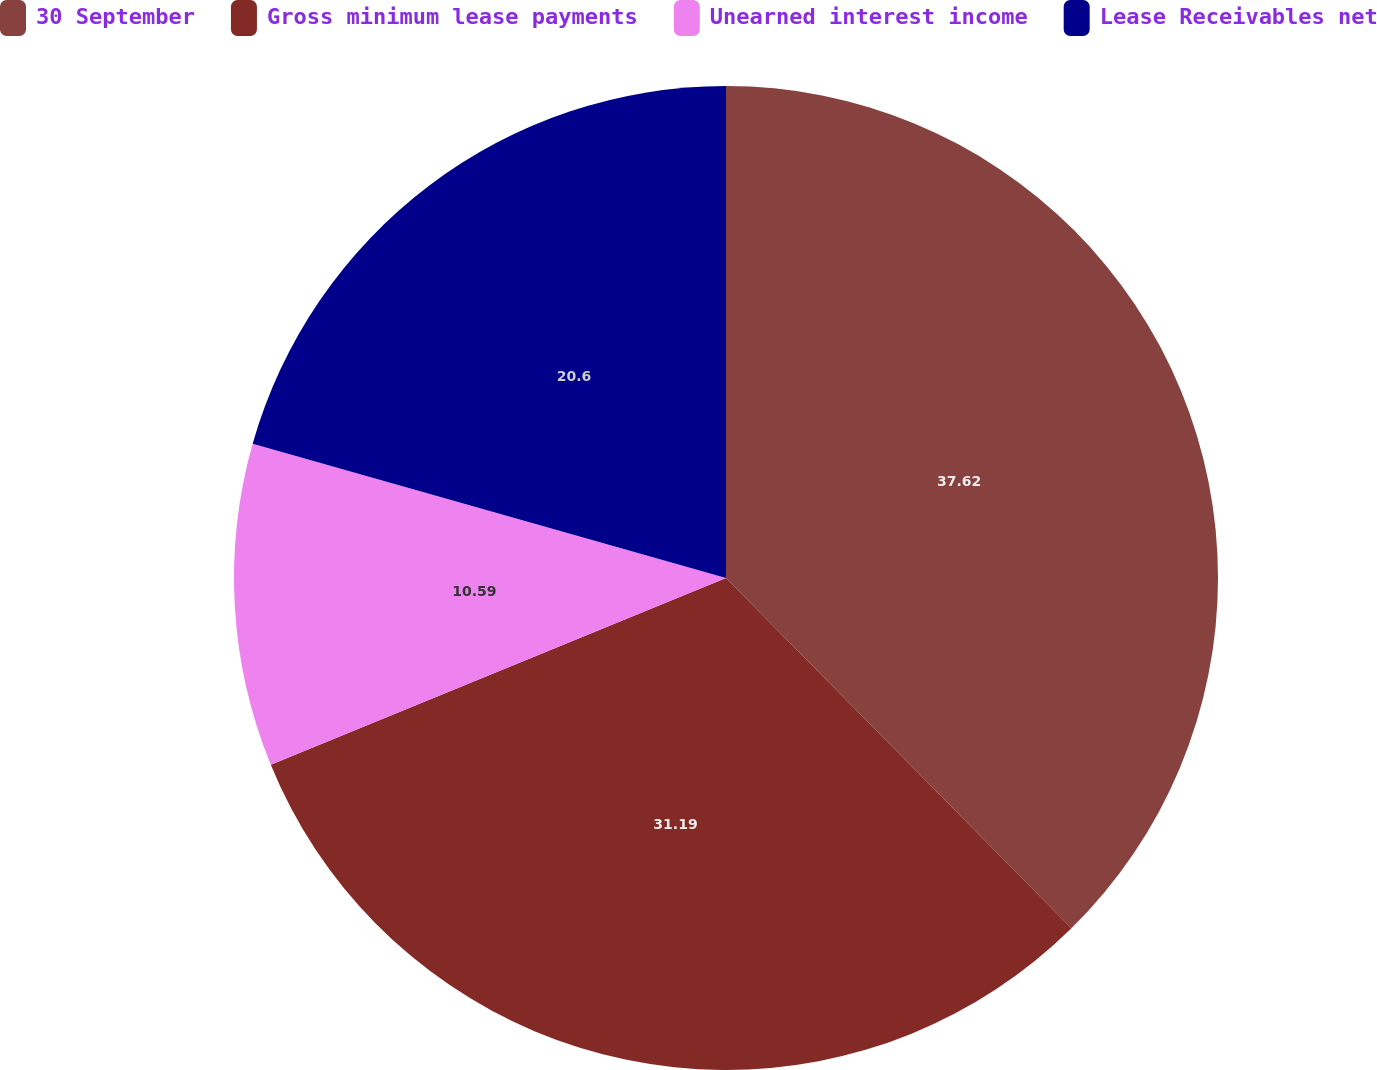Convert chart to OTSL. <chart><loc_0><loc_0><loc_500><loc_500><pie_chart><fcel>30 September<fcel>Gross minimum lease payments<fcel>Unearned interest income<fcel>Lease Receivables net<nl><fcel>37.61%<fcel>31.19%<fcel>10.59%<fcel>20.6%<nl></chart> 